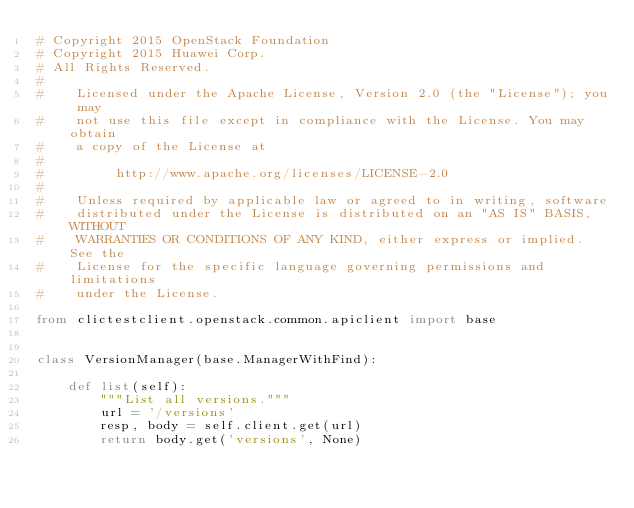Convert code to text. <code><loc_0><loc_0><loc_500><loc_500><_Python_># Copyright 2015 OpenStack Foundation
# Copyright 2015 Huawei Corp.
# All Rights Reserved.
#
#    Licensed under the Apache License, Version 2.0 (the "License"); you may
#    not use this file except in compliance with the License. You may obtain
#    a copy of the License at
#
#         http://www.apache.org/licenses/LICENSE-2.0
#
#    Unless required by applicable law or agreed to in writing, software
#    distributed under the License is distributed on an "AS IS" BASIS, WITHOUT
#    WARRANTIES OR CONDITIONS OF ANY KIND, either express or implied. See the
#    License for the specific language governing permissions and limitations
#    under the License.

from clictestclient.openstack.common.apiclient import base


class VersionManager(base.ManagerWithFind):

    def list(self):
        """List all versions."""
        url = '/versions'
        resp, body = self.client.get(url)
        return body.get('versions', None)
</code> 